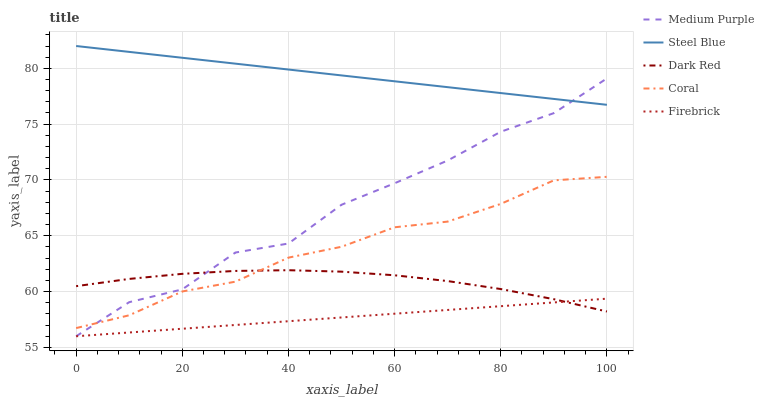Does Firebrick have the minimum area under the curve?
Answer yes or no. Yes. Does Steel Blue have the maximum area under the curve?
Answer yes or no. Yes. Does Dark Red have the minimum area under the curve?
Answer yes or no. No. Does Dark Red have the maximum area under the curve?
Answer yes or no. No. Is Firebrick the smoothest?
Answer yes or no. Yes. Is Medium Purple the roughest?
Answer yes or no. Yes. Is Dark Red the smoothest?
Answer yes or no. No. Is Dark Red the roughest?
Answer yes or no. No. Does Dark Red have the lowest value?
Answer yes or no. No. Does Steel Blue have the highest value?
Answer yes or no. Yes. Does Dark Red have the highest value?
Answer yes or no. No. Is Dark Red less than Steel Blue?
Answer yes or no. Yes. Is Steel Blue greater than Coral?
Answer yes or no. Yes. Does Medium Purple intersect Firebrick?
Answer yes or no. Yes. Is Medium Purple less than Firebrick?
Answer yes or no. No. Is Medium Purple greater than Firebrick?
Answer yes or no. No. Does Dark Red intersect Steel Blue?
Answer yes or no. No. 